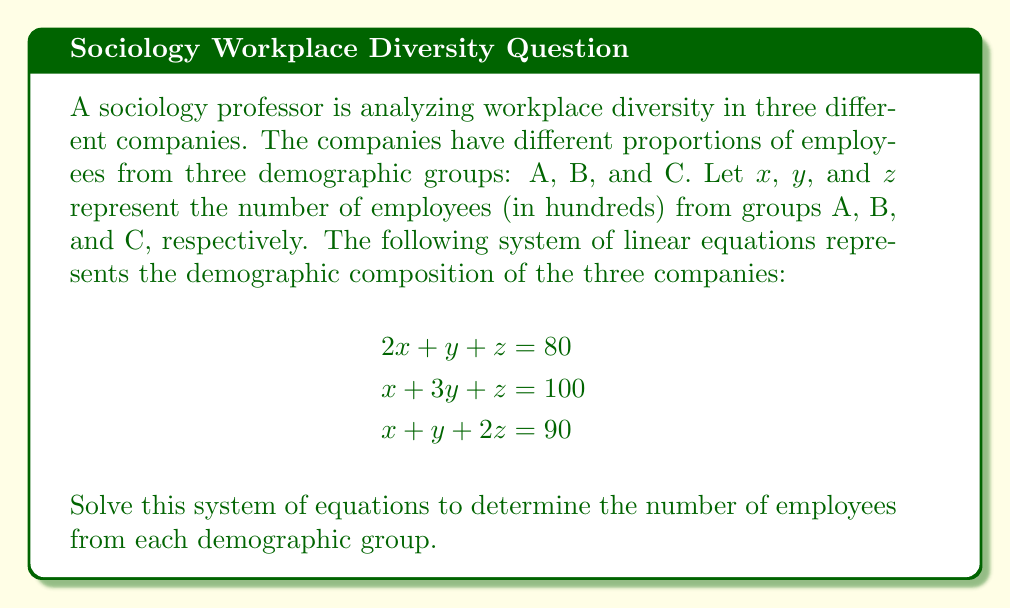Help me with this question. To solve this system of linear equations, we'll use the elimination method:

1) First, let's eliminate $z$ by subtracting equation (1) from equation (3):
   $$(x + y + 2z) - (2x + y + z) = 90 - 80$$
   $$-x + z = 10 \quad \text{(Equation 4)}$$

2) Now, let's eliminate $z$ by subtracting equation (1) from equation (2):
   $$(x + 3y + z) - (2x + y + z) = 100 - 80$$
   $$-x + 2y = 20 \quad \text{(Equation 5)}$$

3) We now have a simpler system with two equations and two unknowns:
   $$\begin{aligned}
   -x + z &= 10 \\
   -x + 2y &= 20
   \end{aligned}$$

4) Subtract equation (4) from equation (5):
   $$2y - z = 10$$
   $$z = 2y - 10 \quad \text{(Equation 6)}$$

5) Substitute this expression for $z$ into equation (4):
   $$-x + (2y - 10) = 10$$
   $$-x + 2y = 20$$
   
   This is the same as equation (5), so we're on the right track.

6) From equation (5), we can express $x$ in terms of $y$:
   $$x = 2y - 20 \quad \text{(Equation 7)}$$

7) Substitute expressions for $x$ and $z$ into equation (1):
   $$2(2y - 20) + y + (2y - 10) = 80$$
   $$4y - 40 + y + 2y - 10 = 80$$
   $$7y = 130$$
   $$y = \frac{130}{7} \approx 18.57$$

8) Now we can find $x$ using equation (7):
   $$x = 2(18.57) - 20 \approx 17.14$$

9) And we can find $z$ using equation (6):
   $$z = 2(18.57) - 10 \approx 27.14$$

Therefore, the solution is approximately:
$x \approx 17.14$, $y \approx 18.57$, $z \approx 27.14$

Remember, these values are in hundreds of employees.
Answer: Group A: approximately 1,714 employees
Group B: approximately 1,857 employees
Group C: approximately 2,714 employees 